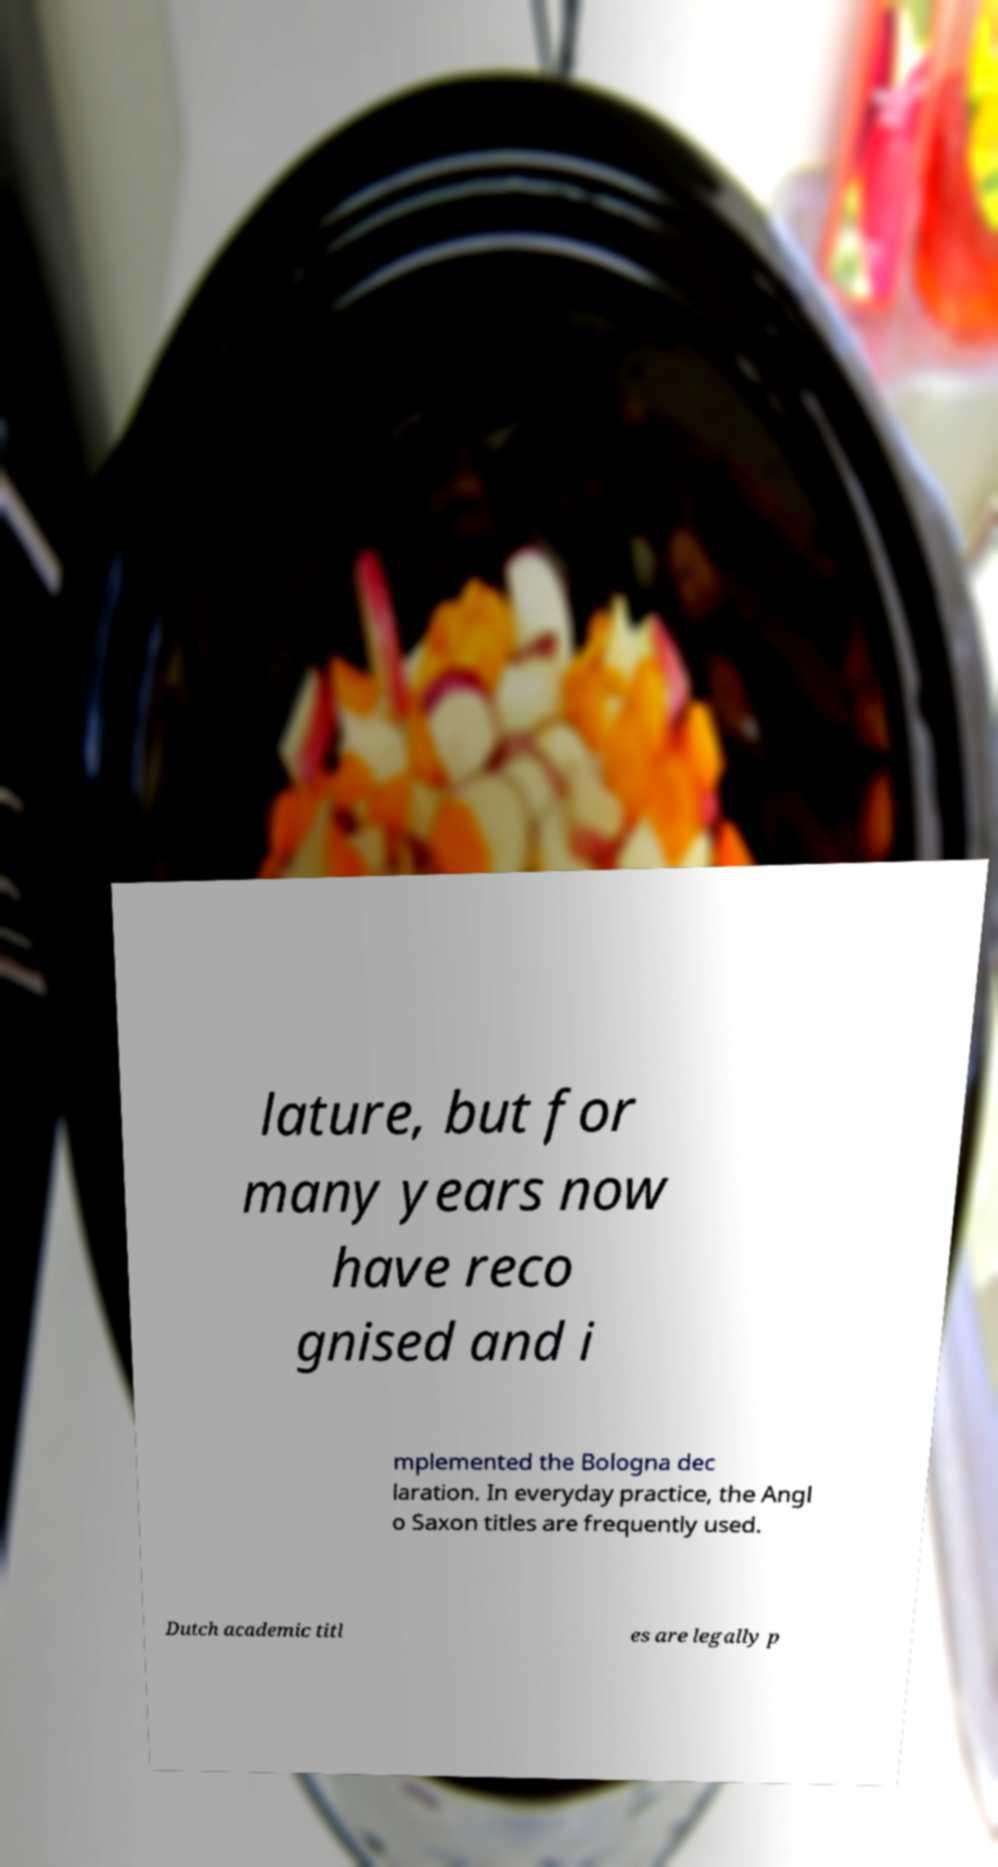Could you assist in decoding the text presented in this image and type it out clearly? lature, but for many years now have reco gnised and i mplemented the Bologna dec laration. In everyday practice, the Angl o Saxon titles are frequently used. Dutch academic titl es are legally p 